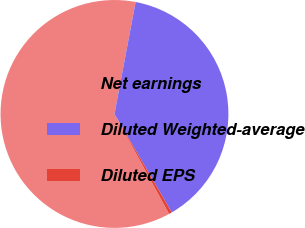Convert chart to OTSL. <chart><loc_0><loc_0><loc_500><loc_500><pie_chart><fcel>Net earnings<fcel>Diluted Weighted-average<fcel>Diluted EPS<nl><fcel>60.93%<fcel>38.64%<fcel>0.43%<nl></chart> 